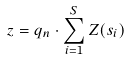Convert formula to latex. <formula><loc_0><loc_0><loc_500><loc_500>z = q _ { n } \cdot \sum _ { i = 1 } ^ { S } Z ( s _ { i } )</formula> 